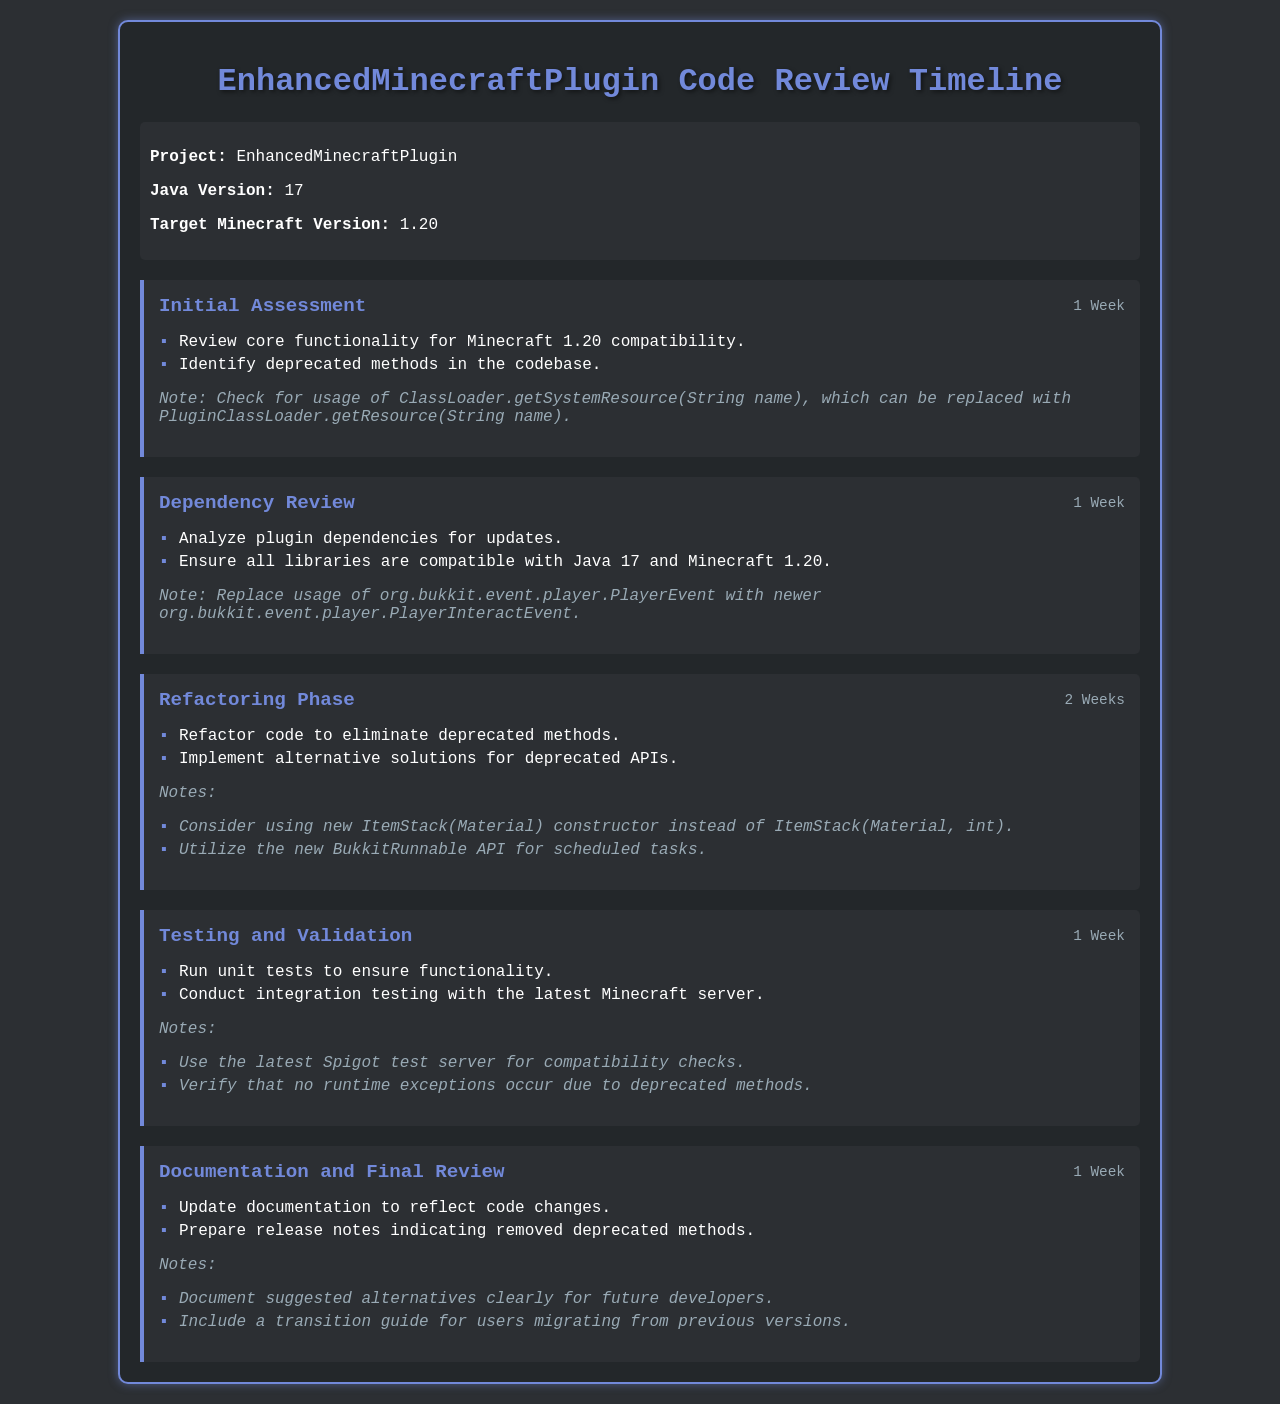What is the project name? The project name is mentioned in the project info section, which is "EnhancedMinecraftPlugin."
Answer: EnhancedMinecraftPlugin How long is the Initial Assessment phase? The duration of the Initial Assessment phase is listed as "1 Week."
Answer: 1 Week What is the target Minecraft version? The target Minecraft version is specified in the project info section as "1.20."
Answer: 1.20 What deprecated method should be checked for usage? The notes in the Initial Assessment phase mention a specific deprecated method to check, which is "ClassLoader.getSystemResource(String name)."
Answer: ClassLoader.getSystemResource(String name) Which event is suggested as a replacement for PlayerEvent? The notes in the Dependency Review phase suggest replacing "org.bukkit.event.player.PlayerEvent" with a newer event, which is "org.bukkit.event.player.PlayerInteractEvent."
Answer: org.bukkit.event.player.PlayerInteractEvent How many weeks are allocated for the Refactoring Phase? The Refactoring Phase duration is explicitly stated as "2 Weeks."
Answer: 2 Weeks What is one of the suggested alternatives for the ItemStack constructor? In the notes of the Refactoring Phase, it suggests using "new ItemStack(Material)" constructor as an alternative.
Answer: new ItemStack(Material) What type of server should be used for compatibility checks? The document specifies that the latest "Spigot test server" should be used for compatibility checks in the Testing and Validation phase.
Answer: Spigot test server What should be updated in the Documentation and Final Review phase? In the Documentation and Final Review phase, it states to "Update documentation to reflect code changes."
Answer: Update documentation to reflect code changes 